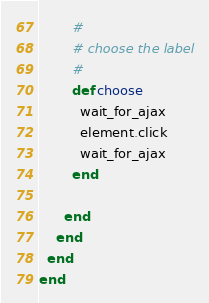<code> <loc_0><loc_0><loc_500><loc_500><_Ruby_>
        #
        # choose the label
        #
        def choose
          wait_for_ajax
          element.click
          wait_for_ajax
        end

      end
    end
  end
end
</code> 